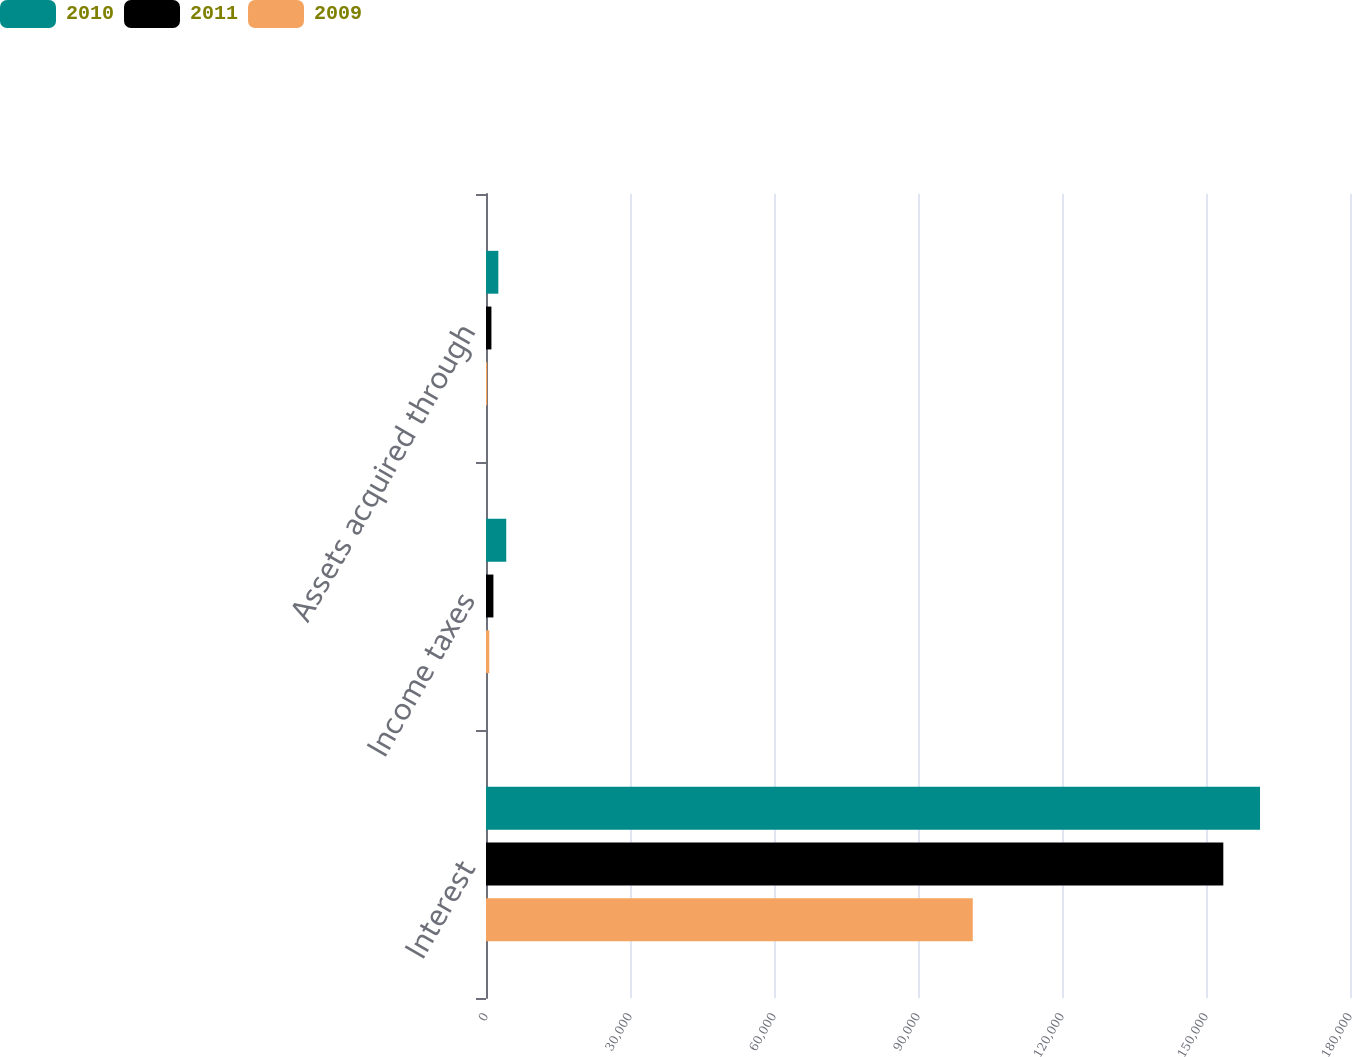Convert chart to OTSL. <chart><loc_0><loc_0><loc_500><loc_500><stacked_bar_chart><ecel><fcel>Interest<fcel>Income taxes<fcel>Assets acquired through<nl><fcel>2010<fcel>161257<fcel>4218<fcel>2570<nl><fcel>2011<fcel>153607<fcel>1545<fcel>1130<nl><fcel>2009<fcel>101409<fcel>684<fcel>239<nl></chart> 